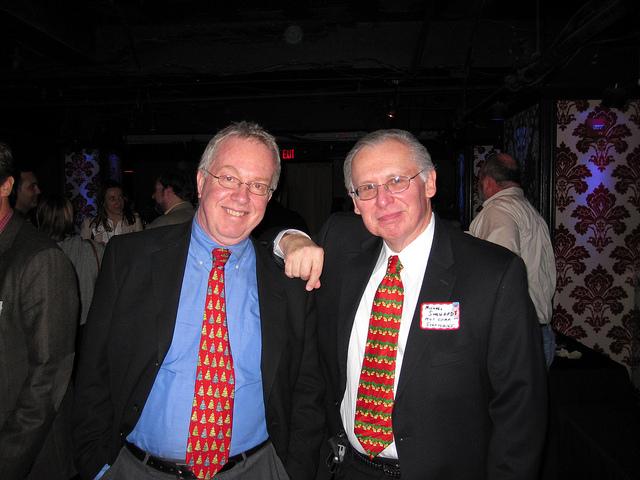Who has the better looking tie?
Short answer required. Both. What is the theme of the men's ties?
Concise answer only. Christmas. Are the men wearing the same tie?
Short answer required. No. What is his badge for?
Write a very short answer. Name. Is the man wearing a goatee?
Short answer required. No. Are they both wearing glasses?
Give a very brief answer. Yes. What matching objects do the men wear?
Answer briefly. Jackets. 